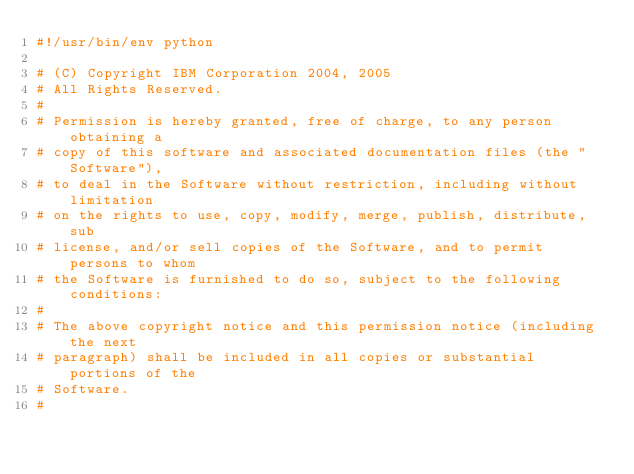<code> <loc_0><loc_0><loc_500><loc_500><_Python_>#!/usr/bin/env python

# (C) Copyright IBM Corporation 2004, 2005
# All Rights Reserved.
#
# Permission is hereby granted, free of charge, to any person obtaining a
# copy of this software and associated documentation files (the "Software"),
# to deal in the Software without restriction, including without limitation
# on the rights to use, copy, modify, merge, publish, distribute, sub
# license, and/or sell copies of the Software, and to permit persons to whom
# the Software is furnished to do so, subject to the following conditions:
#
# The above copyright notice and this permission notice (including the next
# paragraph) shall be included in all copies or substantial portions of the
# Software.
#</code> 